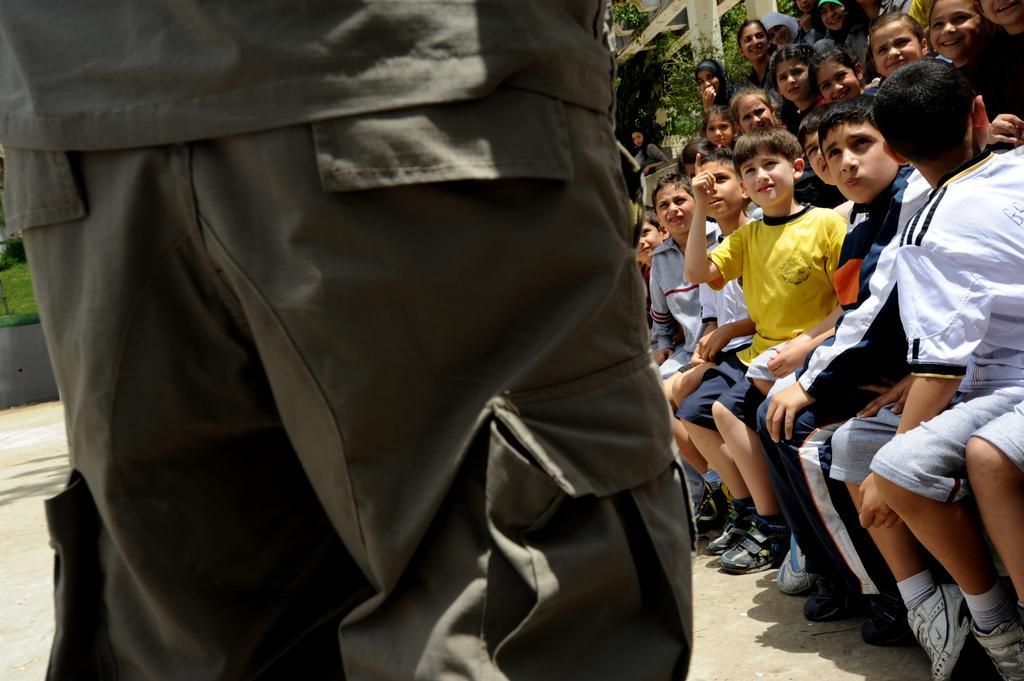How would you summarize this image in a sentence or two? In this picture I can observe a person standing on the left side of the picture. On the right side there are some children sitting. There are boys and girls. In the background I can observe some trees. 